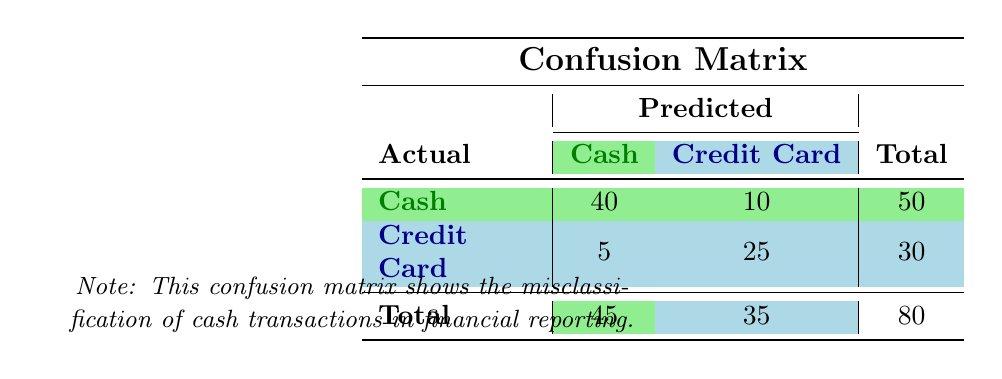What is the number of true positive cash transactions? The true positive cash transactions are represented in the matrix under 'Cash' predicted as 'Cash'. According to the table, this value is 40.
Answer: 40 What is the total number of actual cash transactions? The total number of actual cash transactions can be found in the last column of the actual 'Cash' row, which shows 50.
Answer: 50 How many cash transactions were misclassified as credit card transactions? The number of cash transactions incorrectly classified as credit card transactions is indicated under 'Cash' actual but 'Credit Card' predicted. The value in the matrix is 10.
Answer: 10 What's the total number of false positives in the confusion matrix? To calculate the total number of false positives, we only need to consider the 'Credit Card' row where cash was predicted instead of credit card. From the table, there are 5 false positives.
Answer: 5 What is the accuracy of the classification model? Accuracy is calculated as the sum of true positives and true negatives divided by the total number of predictions. Here, true positives are 40 (cash) and true negatives are 25 (credit card), giving us an accuracy of (40 + 25) / 80 = 0.8125.
Answer: 0.8125 Are there more actual cash transactions than credit card transactions? The actual cash transactions total 50, whereas credit card transactions total 30 as seen in the last row of the table. Yes, there are more actual cash transactions.
Answer: Yes What is the number of total predicted credit card transactions? The total predicted credit card transactions can be found by taking the total from the 'Credit Card' column, which is 35 (5 false positives + 25 true negatives).
Answer: 35 If we only consider the cash transactions, what percentage of them were classified correctly? The percentage of correctly classified cash transactions (true positives) can be calculated using (true positives / total actual cash transactions) * 100. So, (40/50)*100 = 80%.
Answer: 80% What number of actual credit card transactions were misclassified as cash? To find out the actual credit card transactions that were misclassified as cash, we look at the cell under 'Credit Card' actual with 'Cash' predicted, which shows 5.
Answer: 5 